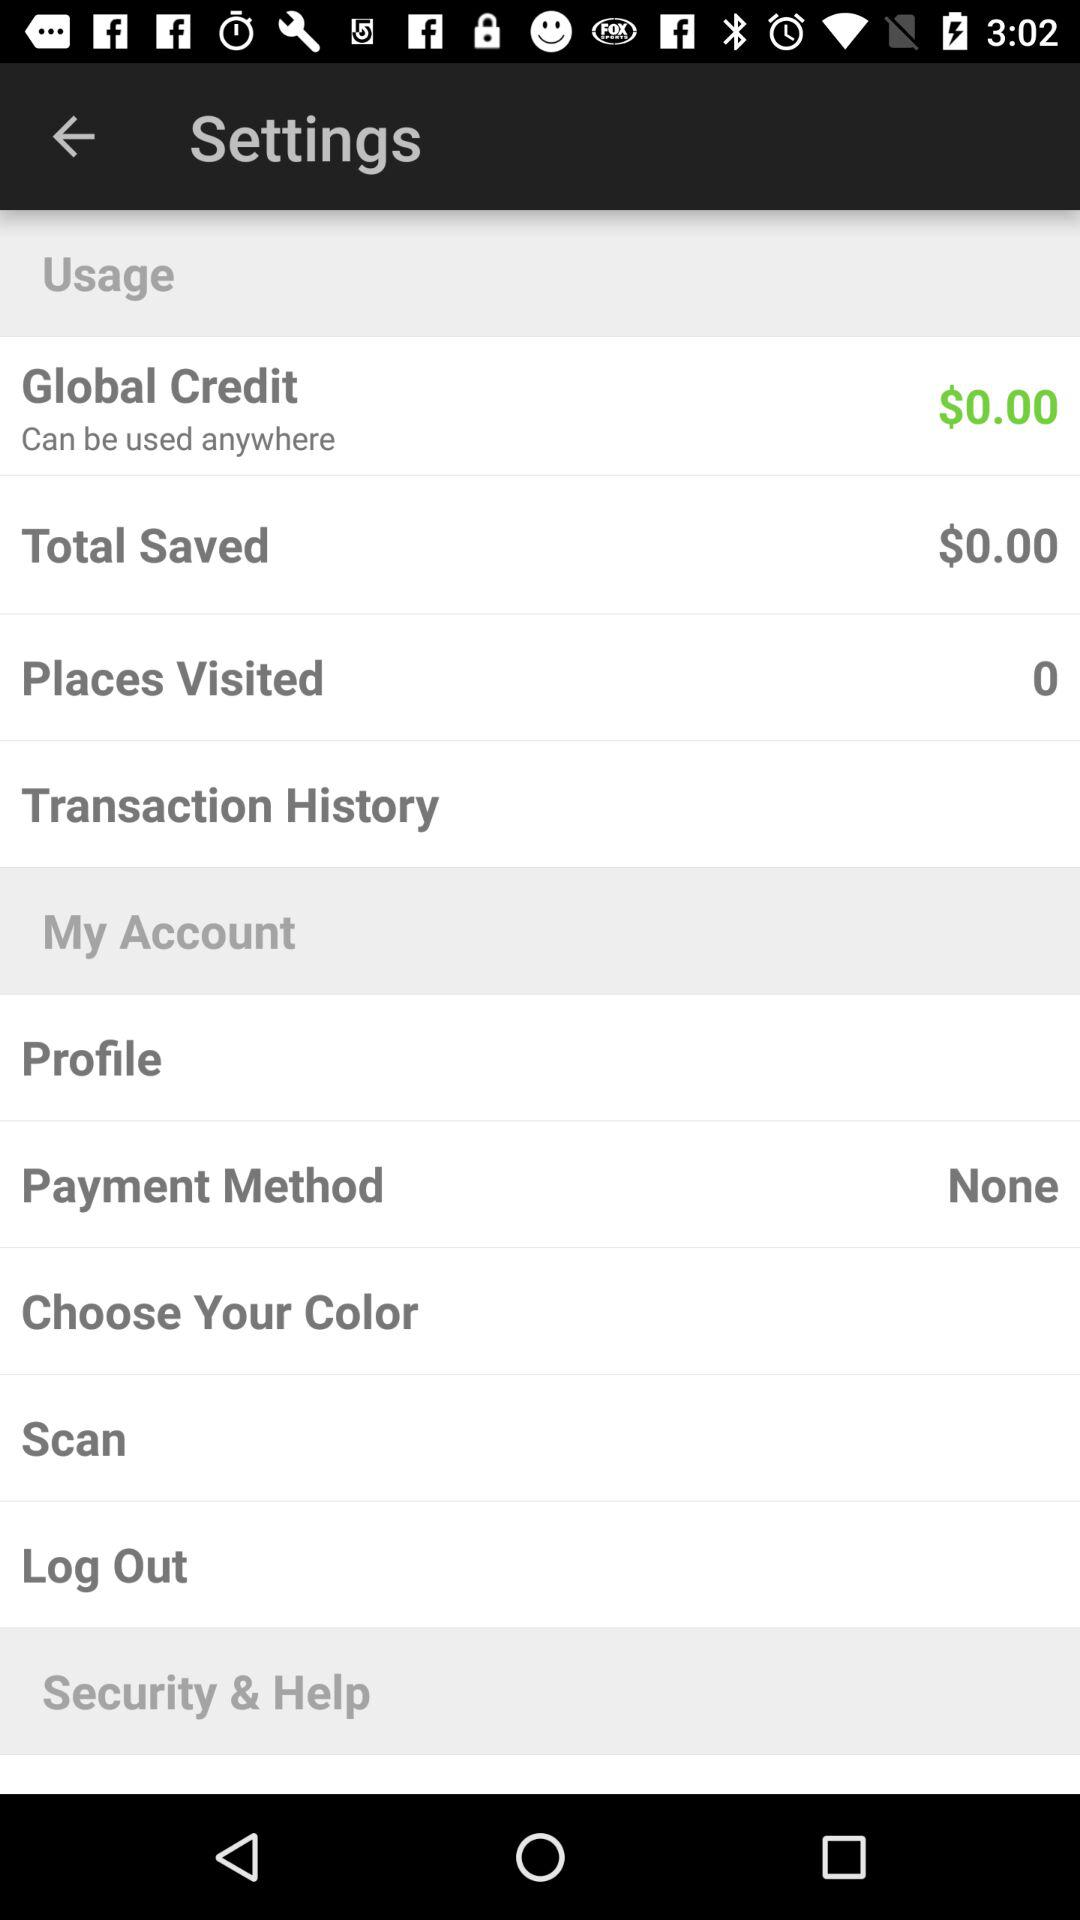What is the selected payment method? The selected payment method is none. 